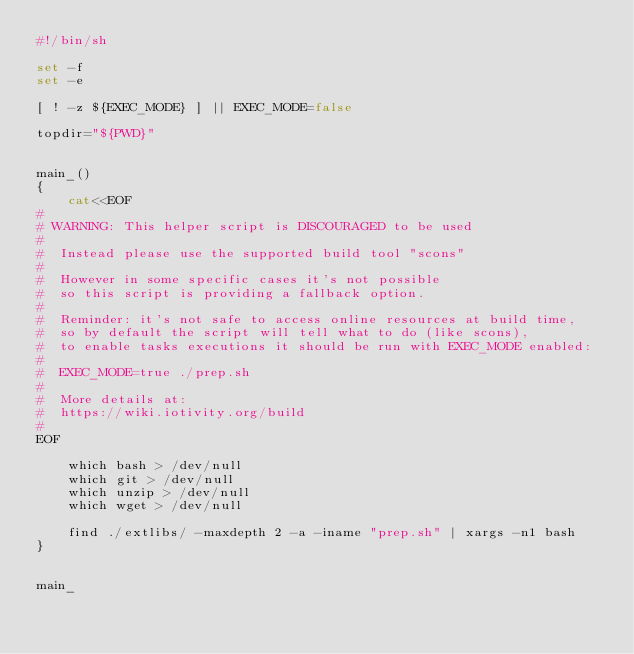<code> <loc_0><loc_0><loc_500><loc_500><_Bash_>#!/bin/sh

set -f
set -e

[ ! -z ${EXEC_MODE} ] || EXEC_MODE=false

topdir="${PWD}"


main_()
{
    cat<<EOF
#
# WARNING: This helper script is DISCOURAGED to be used
#
#  Instead please use the supported build tool "scons"
#
#  However in some specific cases it's not possible
#  so this script is providing a fallback option.
#
#  Reminder: it's not safe to access online resources at build time,
#  so by default the script will tell what to do (like scons),
#  to enable tasks executions it should be run with EXEC_MODE enabled:
#
#  EXEC_MODE=true ./prep.sh
#
#  More details at:
#  https://wiki.iotivity.org/build
#
EOF

    which bash > /dev/null
    which git > /dev/null
    which unzip > /dev/null
    which wget > /dev/null

    find ./extlibs/ -maxdepth 2 -a -iname "prep.sh" | xargs -n1 bash
}


main_
</code> 